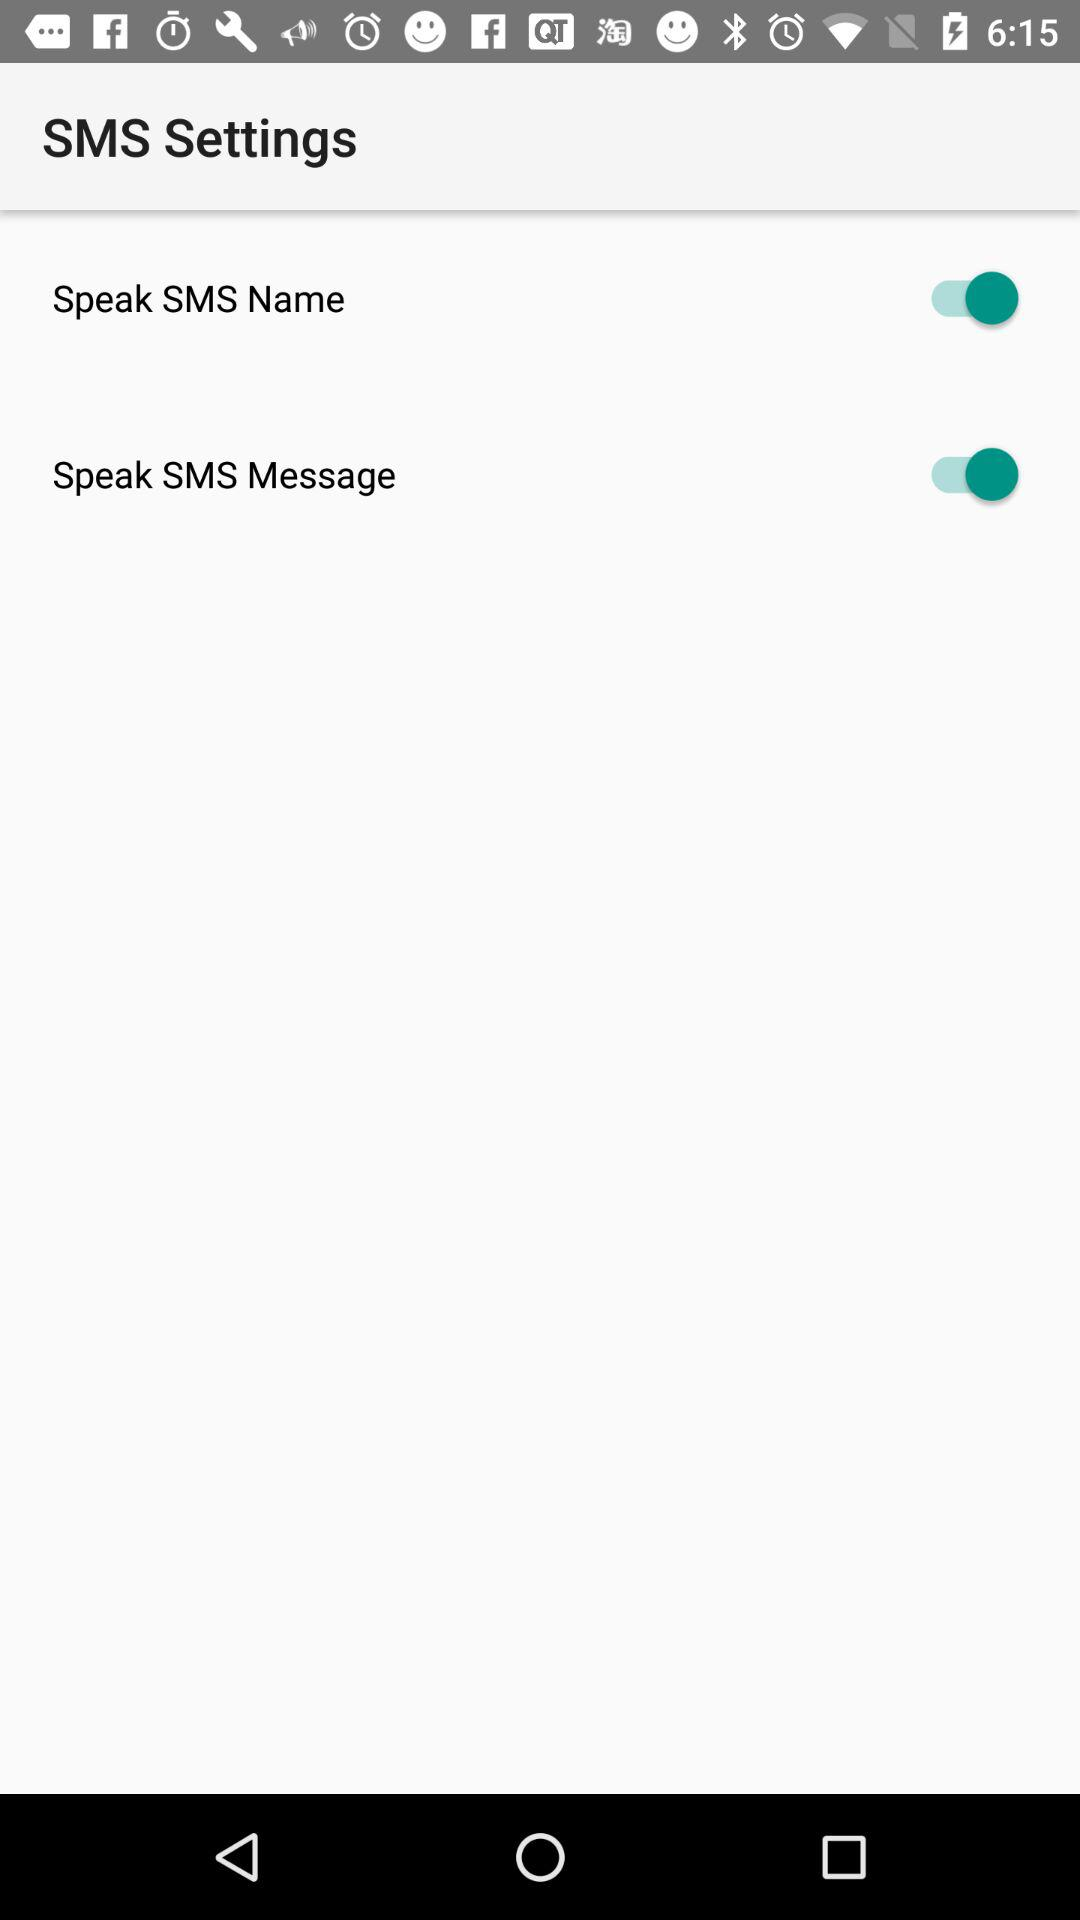What is the status of the Speak SMS message? The status is on. 